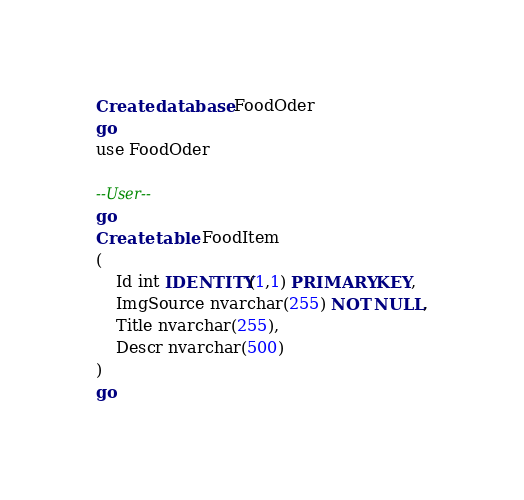<code> <loc_0><loc_0><loc_500><loc_500><_SQL_>Create database FoodOder
go
use FoodOder

--User--
go
Create table FoodItem
(
	Id int IDENTITY(1,1) PRIMARY KEY,
    ImgSource nvarchar(255) NOT NULL,
    Title nvarchar(255),
    Descr nvarchar(500)
)
go</code> 